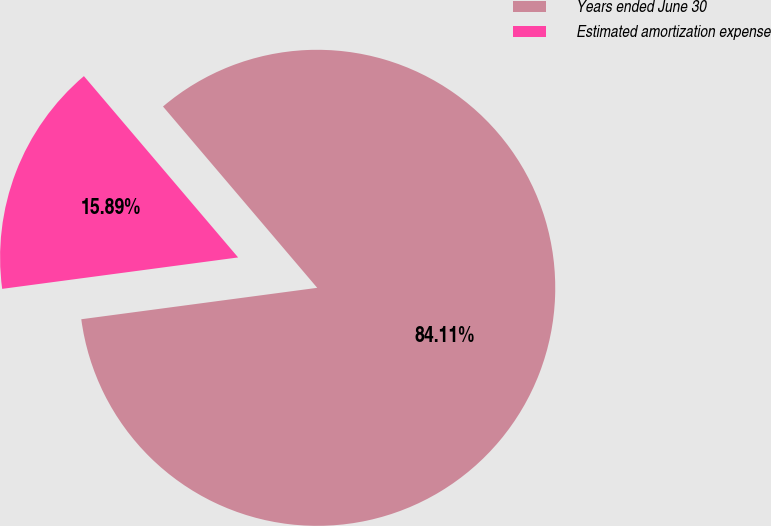Convert chart. <chart><loc_0><loc_0><loc_500><loc_500><pie_chart><fcel>Years ended June 30<fcel>Estimated amortization expense<nl><fcel>84.11%<fcel>15.89%<nl></chart> 